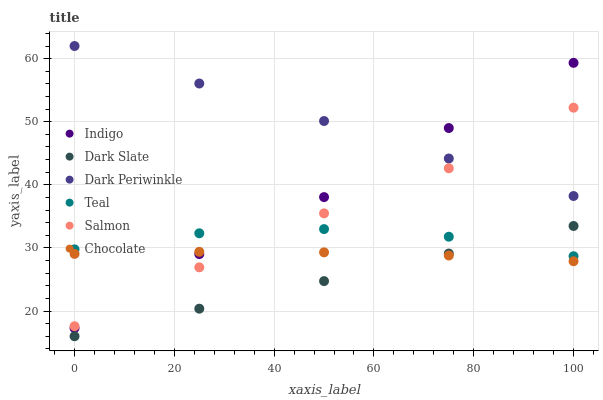Does Dark Slate have the minimum area under the curve?
Answer yes or no. Yes. Does Dark Periwinkle have the maximum area under the curve?
Answer yes or no. Yes. Does Salmon have the minimum area under the curve?
Answer yes or no. No. Does Salmon have the maximum area under the curve?
Answer yes or no. No. Is Dark Slate the smoothest?
Answer yes or no. Yes. Is Teal the roughest?
Answer yes or no. Yes. Is Salmon the smoothest?
Answer yes or no. No. Is Salmon the roughest?
Answer yes or no. No. Does Dark Slate have the lowest value?
Answer yes or no. Yes. Does Salmon have the lowest value?
Answer yes or no. No. Does Dark Periwinkle have the highest value?
Answer yes or no. Yes. Does Salmon have the highest value?
Answer yes or no. No. Is Dark Slate less than Salmon?
Answer yes or no. Yes. Is Dark Periwinkle greater than Teal?
Answer yes or no. Yes. Does Salmon intersect Indigo?
Answer yes or no. Yes. Is Salmon less than Indigo?
Answer yes or no. No. Is Salmon greater than Indigo?
Answer yes or no. No. Does Dark Slate intersect Salmon?
Answer yes or no. No. 